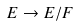<formula> <loc_0><loc_0><loc_500><loc_500>E \rightarrow E / F</formula> 